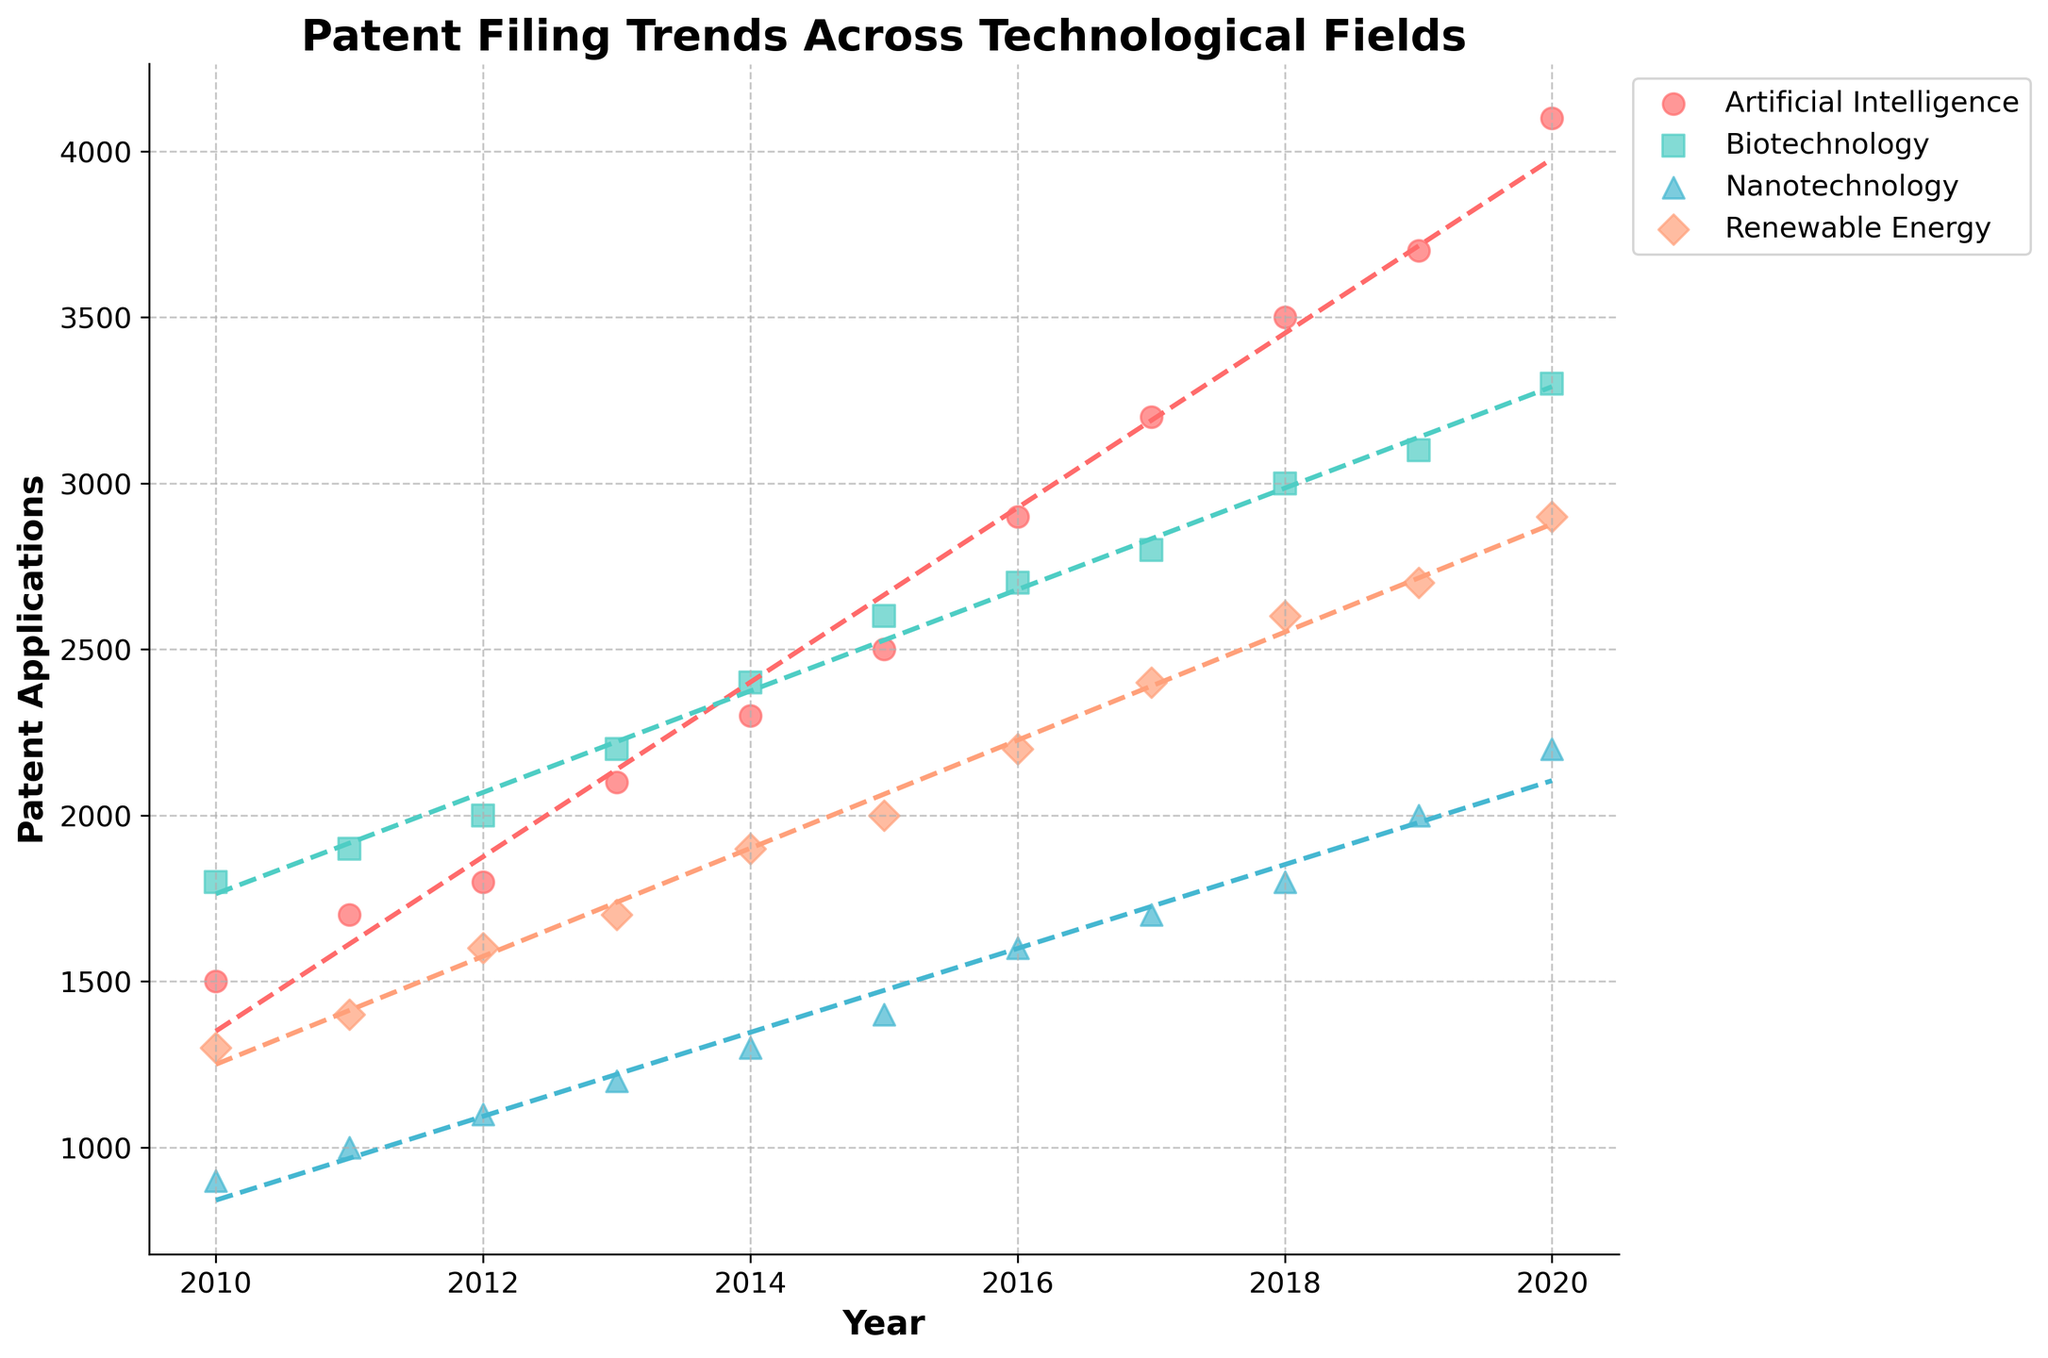what is the title of the plot? The title is located at the top of the plot and summarizes the main focus of the visual data representation. It allows viewers to quickly understand what the plot is about.
Answer: Patent Filing Trends Across Technological Fields Which axis represents the years? The x-axis, which is the horizontal axis, is labeled with "Year" and has tick marks indicating years from 2010 to 2020.
Answer: x-axis Which technological field has the most patent applications in 2020? Looking at the data points on the scatter plot for the year 2020, Artificial Intelligence has the highest number of patent applications.
Answer: Artificial Intelligence How does the trend line for Biotechnology compare to Renewable Energy from 2010 to 2020? Reviewing the trend lines for both technological fields, it's clear that while both show an upward trend, Biotechnology's line has a slightly steeper slope than Renewable Energy, indicating a faster increase in patent filings for Biotechnology.
Answer: Biotechnology has a steeper slope Which field shows the lowest number of patent applications over the observed period? By examining the data points and the general levels of the trend lines on the scatter plot, Nanotechnology has consistently fewer patent applications than the other fields from 2010 to 2020.
Answer: Nanotechnology What is the total number of patent applications in 2017 for all fields combined? Adding the number of patent applications for each field in the year 2017: Artificial Intelligence (3200), Biotechnology (2800), Renewable Energy (2400), Nanotechnology (1700). The total is 3200 + 2800 + 2400 + 1700 = 10100.
Answer: 10100 Which field experienced the greatest increase in patent applications from 2015 to 2020? First, calculate the increase for each field from 2015 to 2020 by subtracting the 2015 values from the 2020 values: AI (4100-2500=1600), Biotechnology (3300-2600=700), Renewable Energy (2900-2000=900), Nanotechnology (2200-1400=800). Artificial Intelligence saw the greatest increase.
Answer: Artificial Intelligence Which of the technological fields appears to have the least steep trend line? Observing the slopes of the trend lines for each field, the Renewable Energy field has the least steep trend line, indicating a slower increase in patent filings compared to other fields.
Answer: Renewable Energy What is the range of patent applications in Nanotechnology from 2010 to 2020? Find the minimum and maximum values of patent applications in the Nanotechnology field over the given period: Minimum (2010) = 900, Maximum (2020) = 2200. The range is 2200 - 900 = 1300.
Answer: 1300 